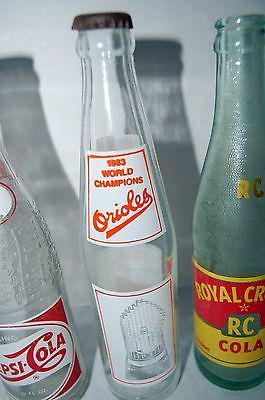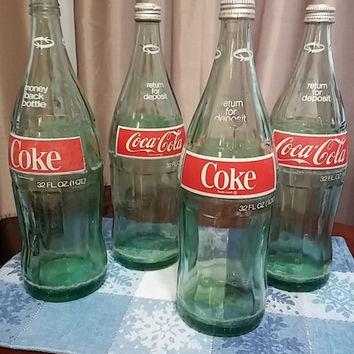The first image is the image on the left, the second image is the image on the right. Given the left and right images, does the statement "The right image includes multiple bottles with the same red-and-white labels, while the left image contains no identical bottles." hold true? Answer yes or no. Yes. The first image is the image on the left, the second image is the image on the right. Given the left and right images, does the statement "The right image contains exactly two bottles." hold true? Answer yes or no. No. 